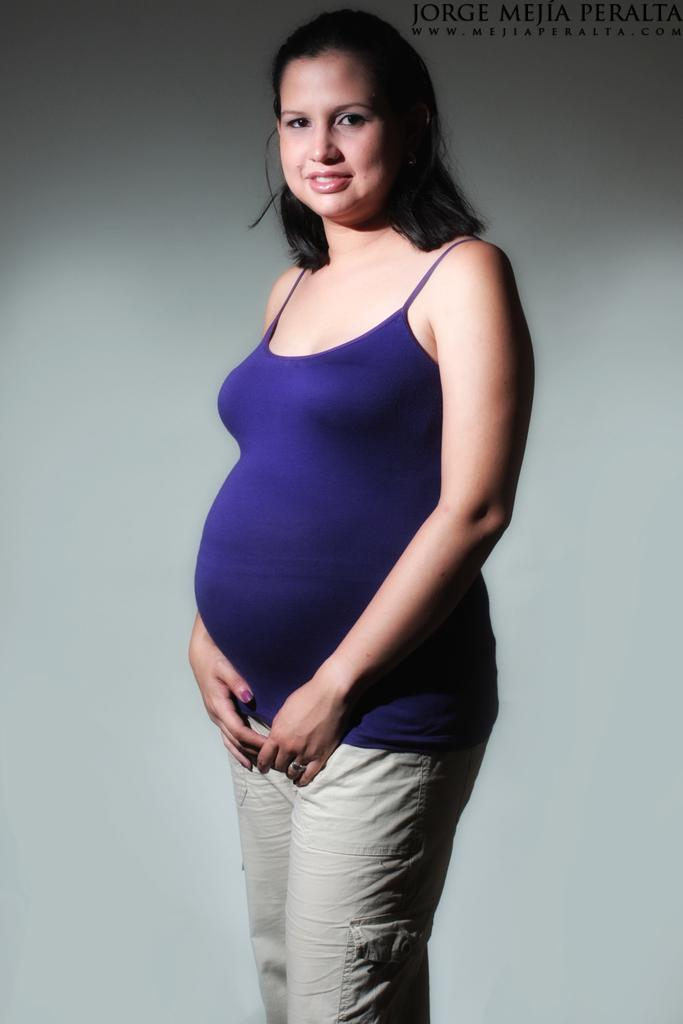What is the color of the wall in the image? There is a white color wall in the image. Who is present in the image? There is a woman in the image. What is the woman wearing? The woman is wearing a blue color dress. What type of oatmeal is the woman eating in the image? There is no oatmeal present in the image, and the woman is not eating anything. 